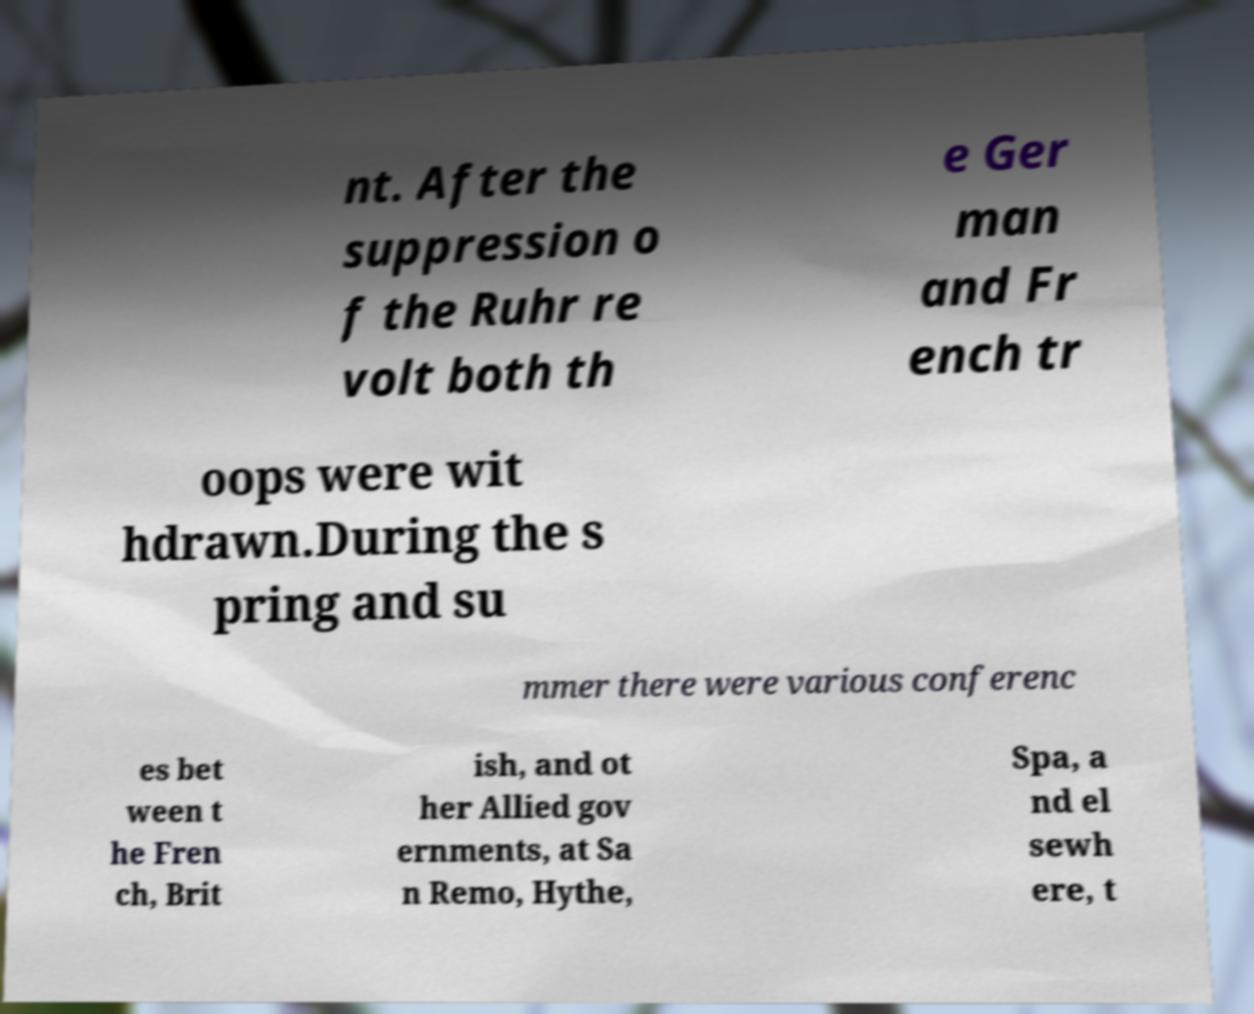Can you accurately transcribe the text from the provided image for me? nt. After the suppression o f the Ruhr re volt both th e Ger man and Fr ench tr oops were wit hdrawn.During the s pring and su mmer there were various conferenc es bet ween t he Fren ch, Brit ish, and ot her Allied gov ernments, at Sa n Remo, Hythe, Spa, a nd el sewh ere, t 